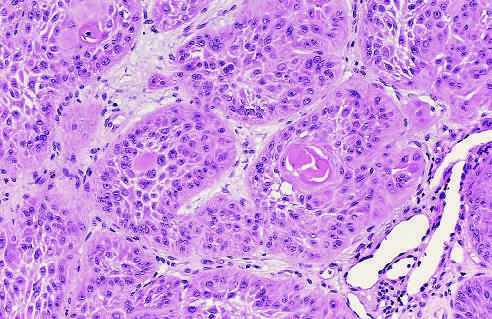how are the tumor cells?
Answer the question using a single word or phrase. Strikingly similar to normal squamous epithelial cells 